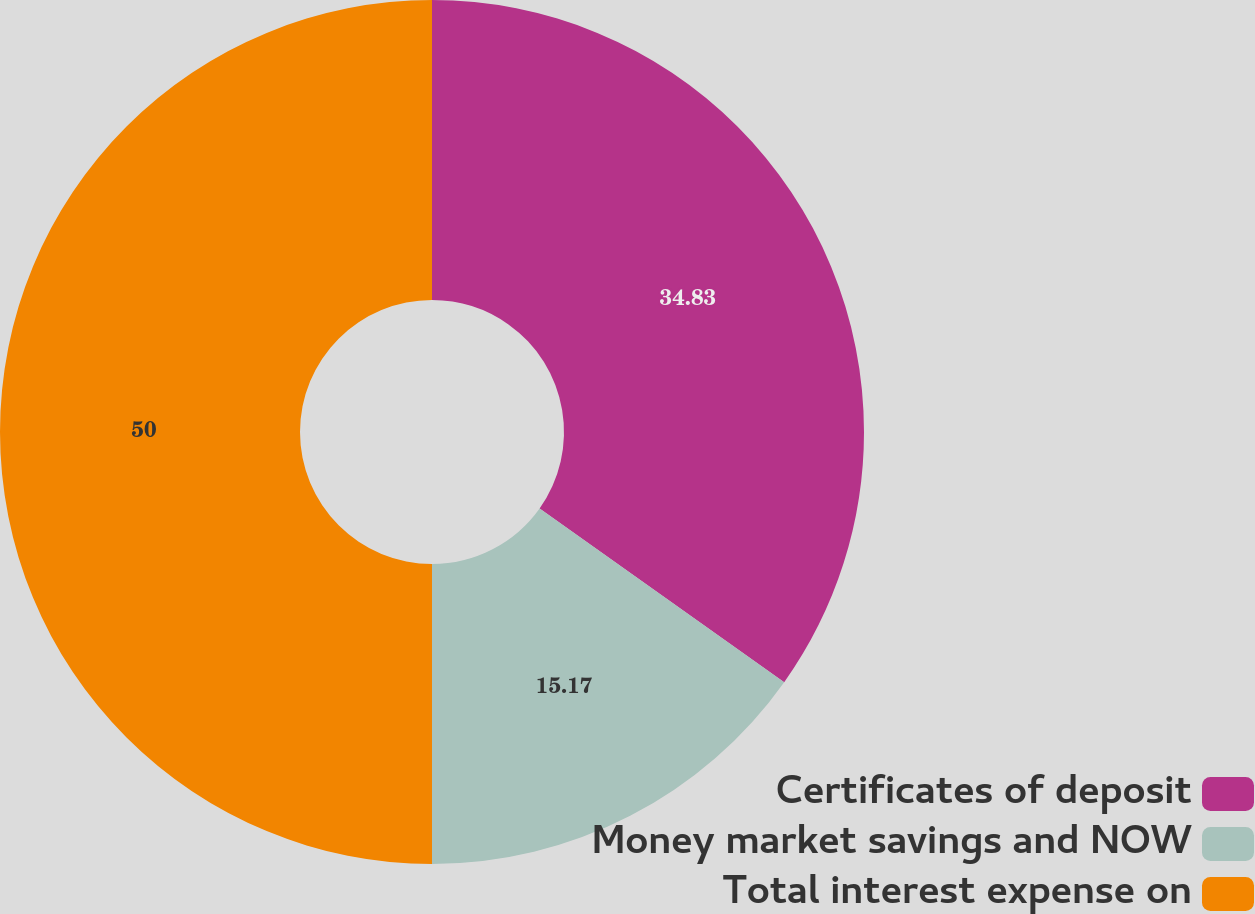Convert chart. <chart><loc_0><loc_0><loc_500><loc_500><pie_chart><fcel>Certificates of deposit<fcel>Money market savings and NOW<fcel>Total interest expense on<nl><fcel>34.83%<fcel>15.17%<fcel>50.0%<nl></chart> 